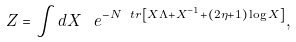Convert formula to latex. <formula><loc_0><loc_0><loc_500><loc_500>Z = \int d X \, \ e ^ { - N \ t r \left [ X \Lambda + X ^ { - 1 } + ( 2 \eta + 1 ) \log X \right ] } ,</formula> 